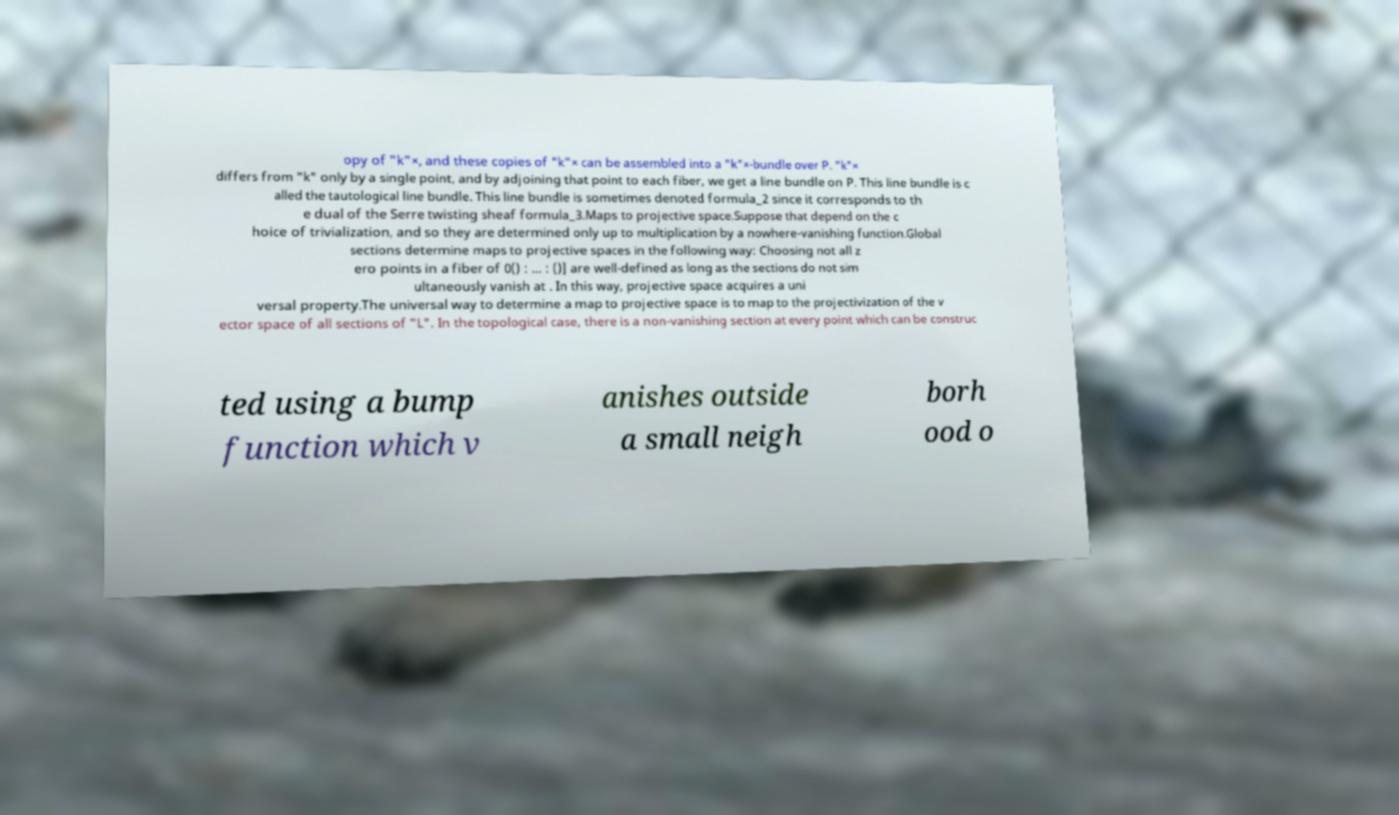Can you read and provide the text displayed in the image?This photo seems to have some interesting text. Can you extract and type it out for me? opy of "k"×, and these copies of "k"× can be assembled into a "k"×-bundle over P. "k"× differs from "k" only by a single point, and by adjoining that point to each fiber, we get a line bundle on P. This line bundle is c alled the tautological line bundle. This line bundle is sometimes denoted formula_2 since it corresponds to th e dual of the Serre twisting sheaf formula_3.Maps to projective space.Suppose that depend on the c hoice of trivialization, and so they are determined only up to multiplication by a nowhere-vanishing function.Global sections determine maps to projective spaces in the following way: Choosing not all z ero points in a fiber of 0() : ... : ()] are well-defined as long as the sections do not sim ultaneously vanish at . In this way, projective space acquires a uni versal property.The universal way to determine a map to projective space is to map to the projectivization of the v ector space of all sections of "L". In the topological case, there is a non-vanishing section at every point which can be construc ted using a bump function which v anishes outside a small neigh borh ood o 